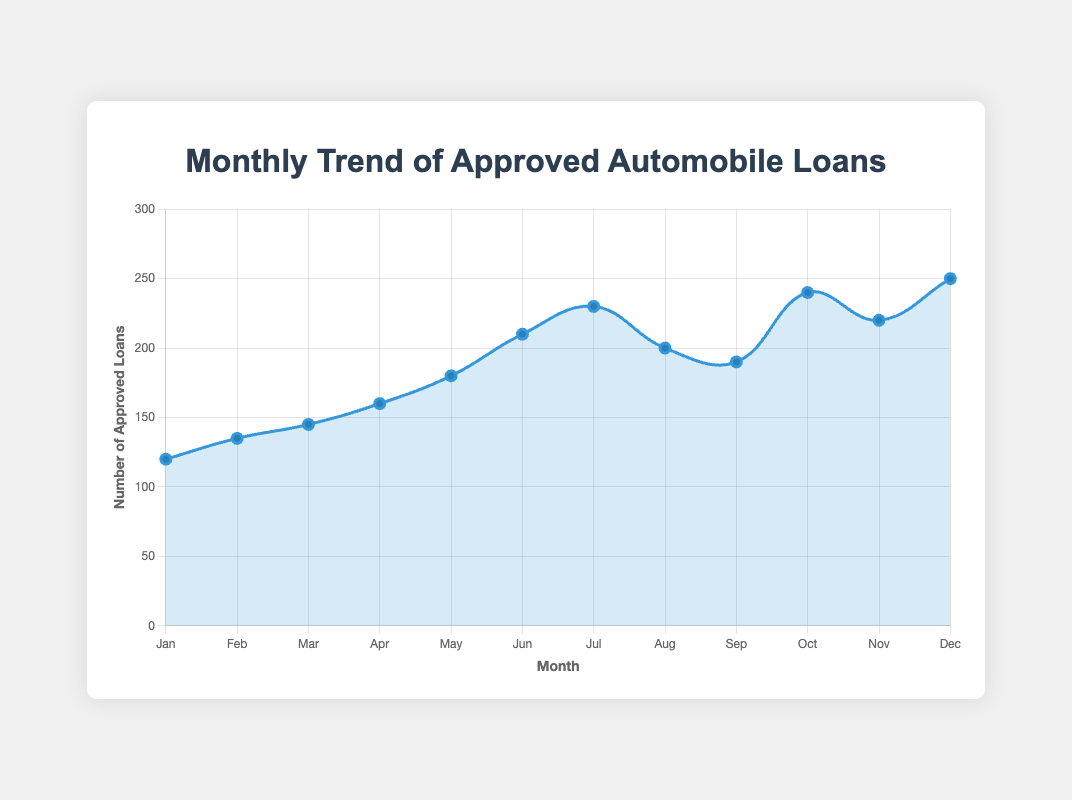Which month had the highest number of approved loans? By looking at the height of the lines and the values plotted for each month, December has the highest number with 250 approved loans.
Answer: December Which month shows the first significant drop in the number of approved loans after continuously increasing? From January to July, the number of approved loans increases. In August, there is a drop from 230 in July to 200 in August.
Answer: August What is the difference in the number of approved loans between May and June? The number of approved loans in May is 180 and in June is 210. The difference is 210 - 180 = 30.
Answer: 30 Between which two consecutive months is the increase in approved loans the largest? The largest increase is between September (190) and October (240). The increase is 240 - 190 = 50.
Answer: September to October What is the average number of approved loans over the entire year? Adding up the approved loans for each month: 120 + 135 + 145 + 160 + 180 + 210 + 230 + 200 + 190 + 240 + 220 + 250 = 2280. There are 12 months, so the average is 2280/12 = 190.
Answer: 190 Which month had the lowest number of approved loans? By comparing the values for each month, January has the lowest number with 120 approved loans.
Answer: January How did the number of approved loans change from June to July? In June, the number of approved loans was 210. In July, it increased to 230. The change is 230 - 210 = 20.
Answer: Increased by 20 What is the general trend of approved loans from January to December? The general trend is an overall increase in the number of approved loans, with some variations in certain months like August and September.
Answer: Increasing How many months had approved loans above 200? The months with approved loans above 200 are June (210), July (230), October (240), November (220), and December (250). There are 5 such months.
Answer: 5 What is the median number of approved loans for the year? Sorting the numbers: 120, 135, 145, 160, 180, 190, 200, 210, 220, 230, 240, 250. The median is the average of the 6th and 7th values in this ordered list: (190 + 200) / 2 = 195.
Answer: 195 